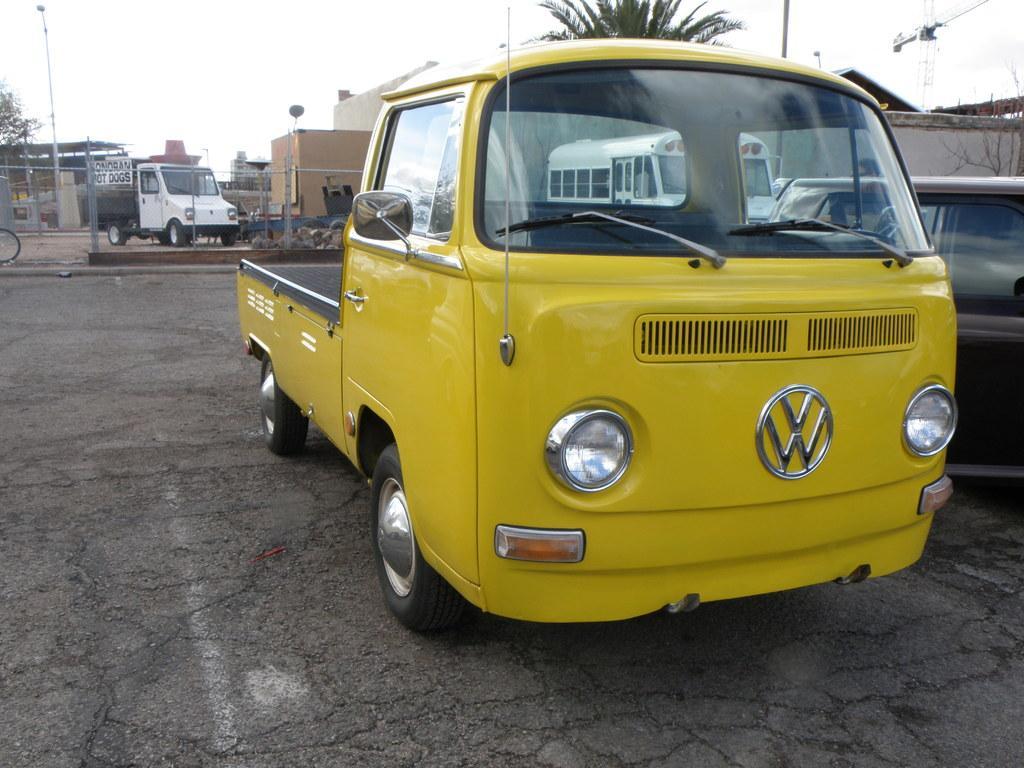Please provide a concise description of this image. This picture is clicked outside. On the right there is a yellow color vehicle parked on the ground. In the center we can see the buildings, trees and a white color vehicle and some other objects. On the right corner there are some vehicles seems to be parked on the ground. In the background we can see the sky and buildings. 